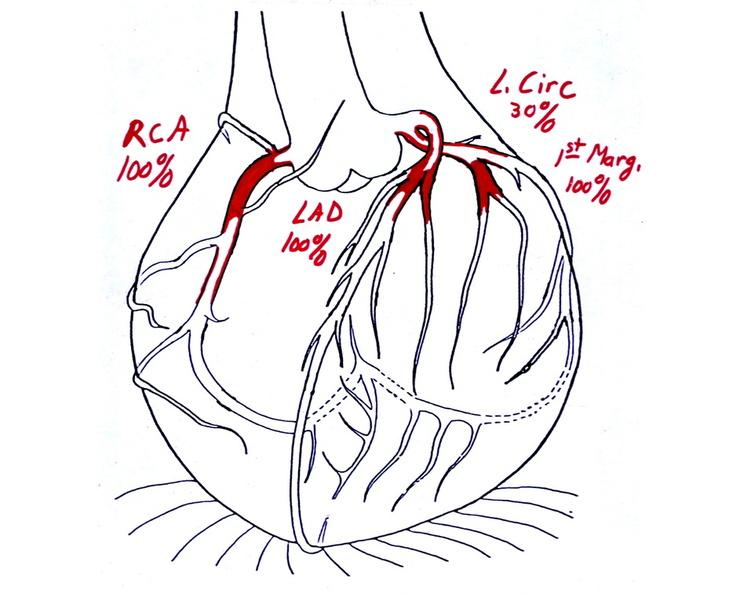what does this image show?
Answer the question using a single word or phrase. Coronary artery atherosclerosis diagram 